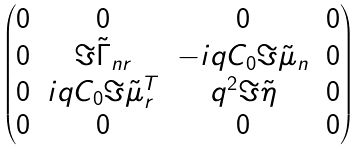Convert formula to latex. <formula><loc_0><loc_0><loc_500><loc_500>\begin{pmatrix} 0 & 0 & 0 & 0 \\ 0 & \Im \tilde { \Gamma } _ { n r } & - i q C _ { 0 } \Im \tilde { \mu } _ { n } & 0 \\ 0 & i q C _ { 0 } \Im \tilde { \mu } ^ { T } _ { r } & q ^ { 2 } \Im \tilde { \eta } & 0 \\ 0 & 0 & 0 & 0 \end{pmatrix}</formula> 